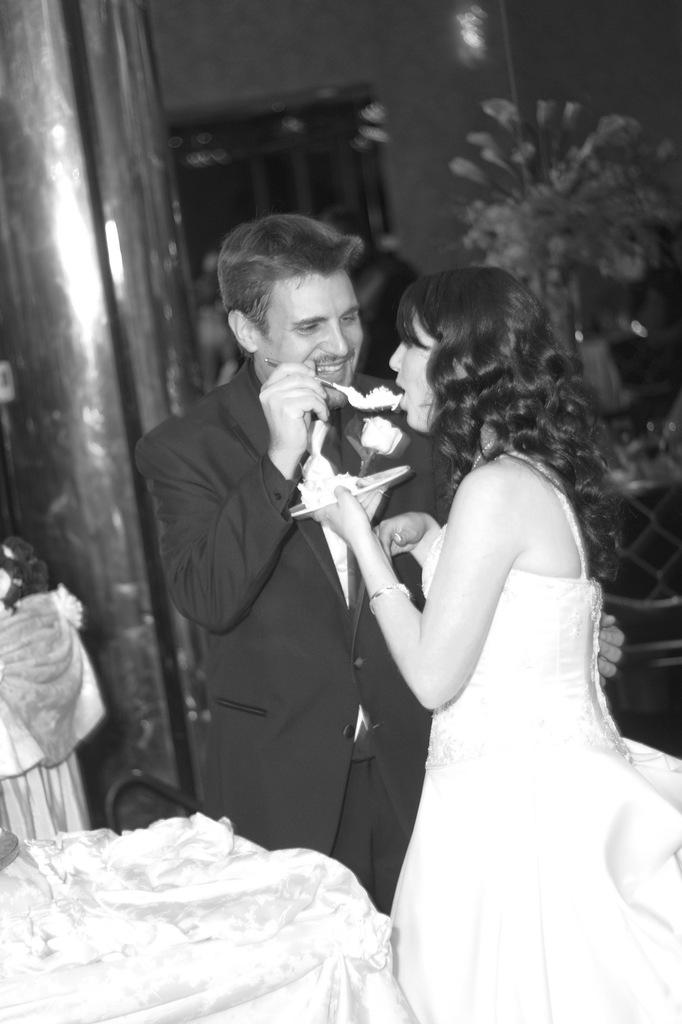How many people are in the image? There are two people in the image. What are the people holding in their hands? The people are holding plates and spoons. What architectural feature can be seen in the image? There is a pillar visible in the image. What type of decorative item is present in the image? There is a flower vase in the image. What type of background is visible in the image? There is a wall in the image. What is the color scheme of the image? The image is black and white. What type of sheet is draped over the pillar in the image? There is no sheet present in the image; only a pillar is visible. How many toes can be seen on the people in the image? The image is black and white and does not show the people's feet, so it is not possible to determine the number of toes. 